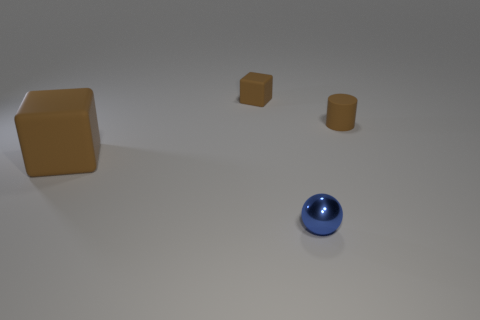Add 1 red balls. How many objects exist? 5 Subtract all spheres. How many objects are left? 3 Subtract 0 yellow cylinders. How many objects are left? 4 Subtract all large purple metal blocks. Subtract all small blue shiny balls. How many objects are left? 3 Add 4 balls. How many balls are left? 5 Add 3 big green things. How many big green things exist? 3 